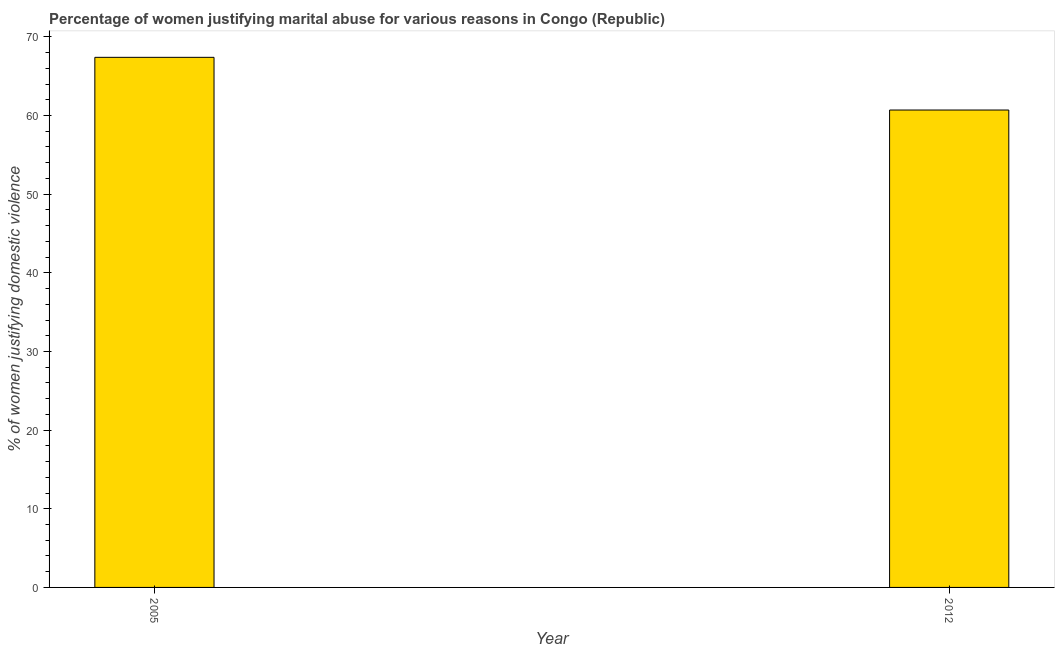What is the title of the graph?
Offer a terse response. Percentage of women justifying marital abuse for various reasons in Congo (Republic). What is the label or title of the X-axis?
Your response must be concise. Year. What is the label or title of the Y-axis?
Ensure brevity in your answer.  % of women justifying domestic violence. What is the percentage of women justifying marital abuse in 2012?
Offer a terse response. 60.7. Across all years, what is the maximum percentage of women justifying marital abuse?
Provide a short and direct response. 67.4. Across all years, what is the minimum percentage of women justifying marital abuse?
Give a very brief answer. 60.7. What is the sum of the percentage of women justifying marital abuse?
Your answer should be compact. 128.1. What is the difference between the percentage of women justifying marital abuse in 2005 and 2012?
Give a very brief answer. 6.7. What is the average percentage of women justifying marital abuse per year?
Offer a very short reply. 64.05. What is the median percentage of women justifying marital abuse?
Keep it short and to the point. 64.05. In how many years, is the percentage of women justifying marital abuse greater than 4 %?
Your answer should be compact. 2. What is the ratio of the percentage of women justifying marital abuse in 2005 to that in 2012?
Your response must be concise. 1.11. In how many years, is the percentage of women justifying marital abuse greater than the average percentage of women justifying marital abuse taken over all years?
Make the answer very short. 1. Are all the bars in the graph horizontal?
Give a very brief answer. No. Are the values on the major ticks of Y-axis written in scientific E-notation?
Your answer should be very brief. No. What is the % of women justifying domestic violence of 2005?
Provide a short and direct response. 67.4. What is the % of women justifying domestic violence in 2012?
Provide a succinct answer. 60.7. What is the ratio of the % of women justifying domestic violence in 2005 to that in 2012?
Your answer should be compact. 1.11. 